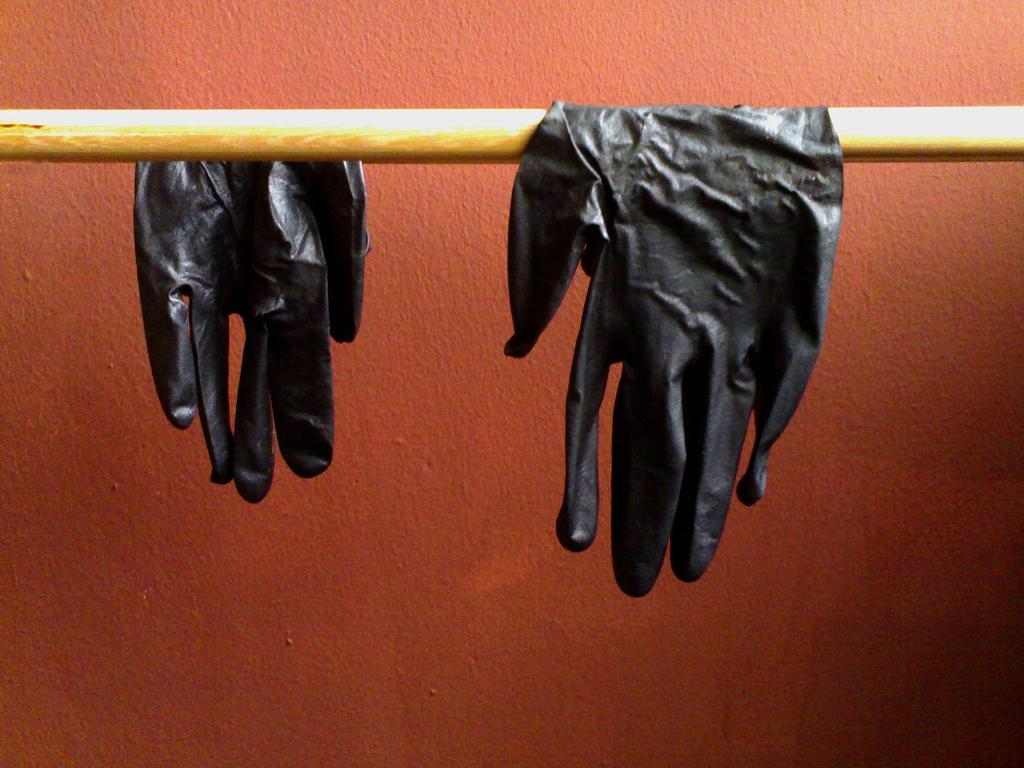What objects are on a stick in the image? There are gloves on a stick in the image. What can be seen in the background of the image? There is a wall visible in the background of the image. How many clocks are hanging on the wall in the image? There are no clocks visible in the image; only a wall is present in the background. 